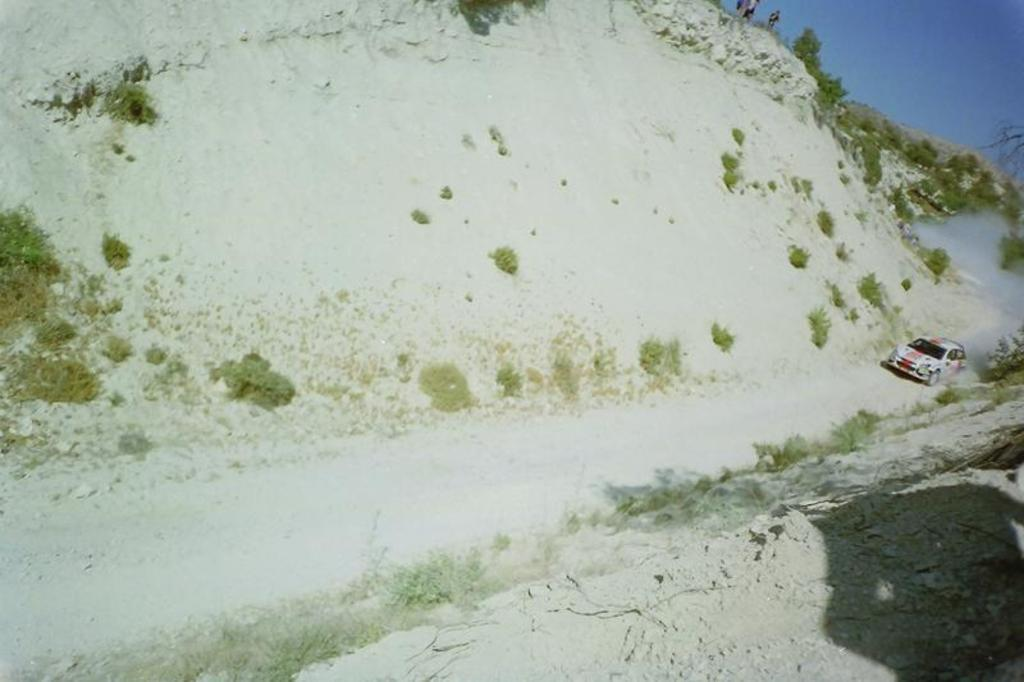What is the main subject of the image? The main subject of the image is a car moving. What can be seen in the background of the image? There are plants and a tree visible in the image. Are there any people present in the image? Yes, there are people standing in the image. What is the color of the sky in the image? The sky is blue in the image. What else can be observed in the image? There is smoke visible in the image. Can you see a rabbit playing with a string in the image? No, there is no rabbit or string present in the image. Is anyone experiencing pain in the image? There is no indication of pain or any emotional state in the image; it only shows a car moving, people standing, and other visual elements. 